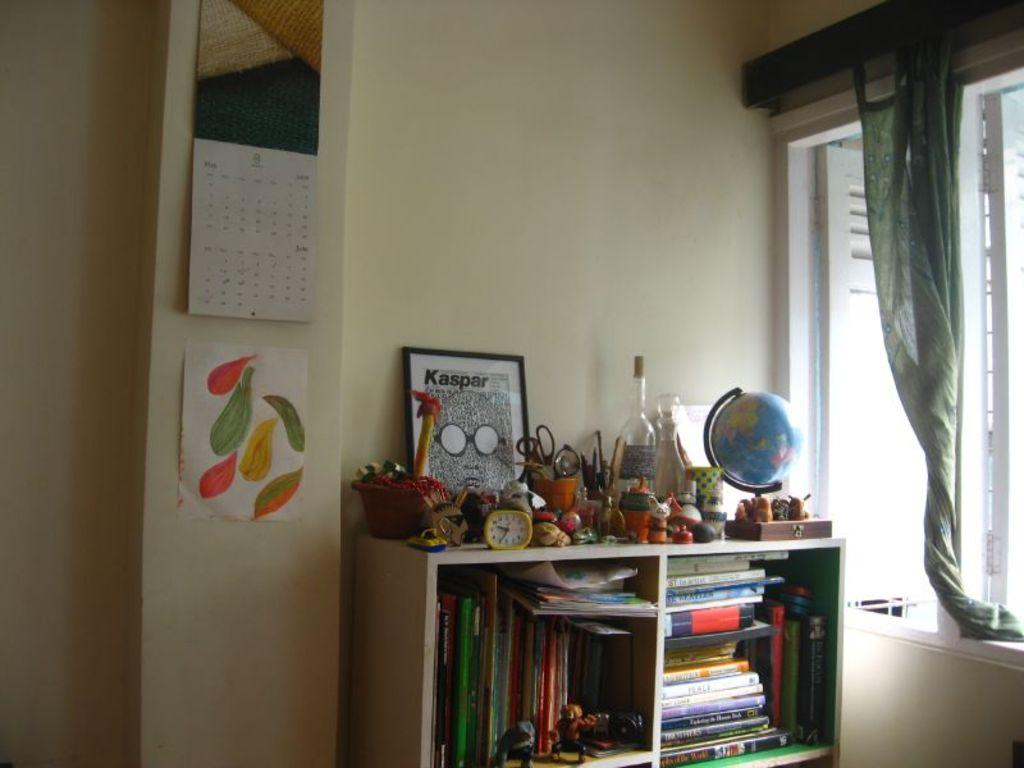<image>
Relay a brief, clear account of the picture shown. A Kaspar art piece leans against a wall. 